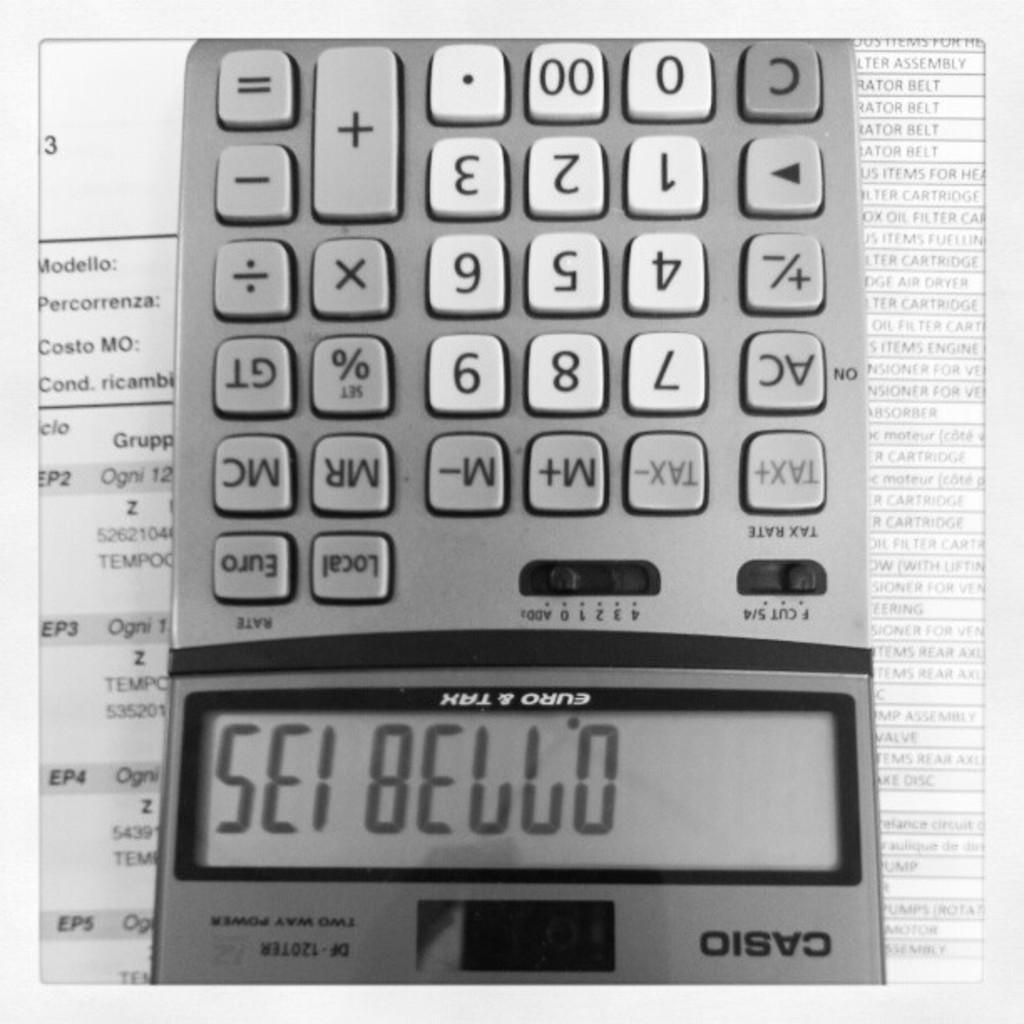<image>
Render a clear and concise summary of the photo. A calculator is upside down it is the casio brand. 